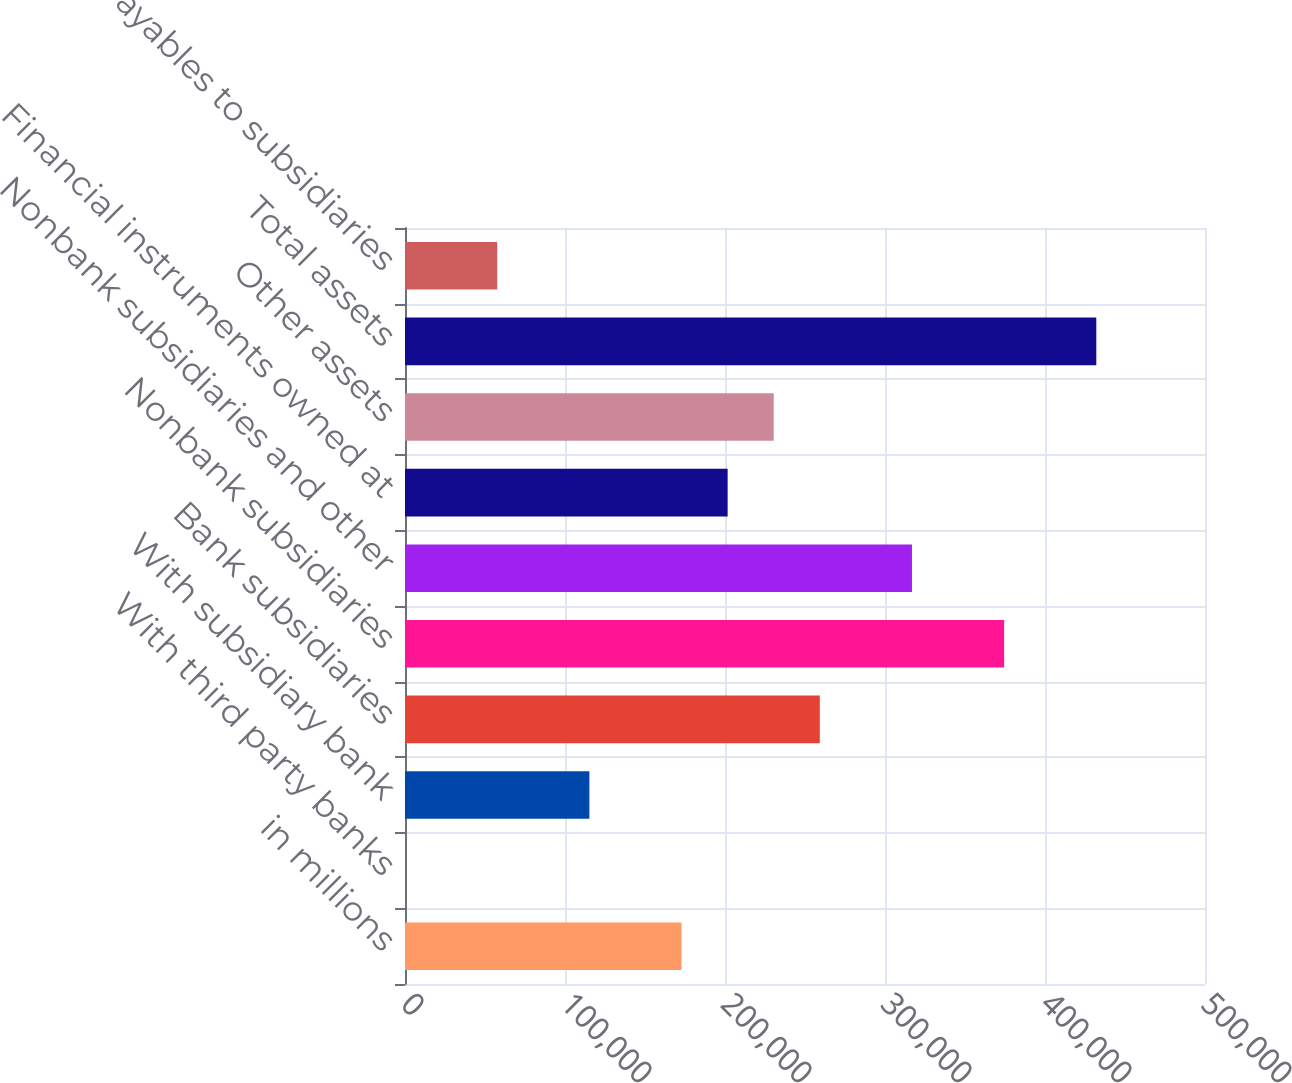Convert chart to OTSL. <chart><loc_0><loc_0><loc_500><loc_500><bar_chart><fcel>in millions<fcel>With third party banks<fcel>With subsidiary bank<fcel>Bank subsidiaries<fcel>Nonbank subsidiaries<fcel>Nonbank subsidiaries and other<fcel>Financial instruments owned at<fcel>Other assets<fcel>Total assets<fcel>Payables to subsidiaries<nl><fcel>172848<fcel>36<fcel>115244<fcel>259254<fcel>374462<fcel>316858<fcel>201650<fcel>230452<fcel>432066<fcel>57640<nl></chart> 